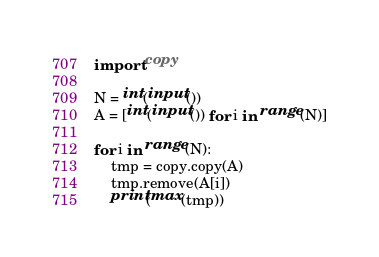<code> <loc_0><loc_0><loc_500><loc_500><_Python_>import copy

N = int(input())
A = [int(input()) for i in range(N)]

for i in range(N):
    tmp = copy.copy(A)
    tmp.remove(A[i])
    print(max(tmp))</code> 